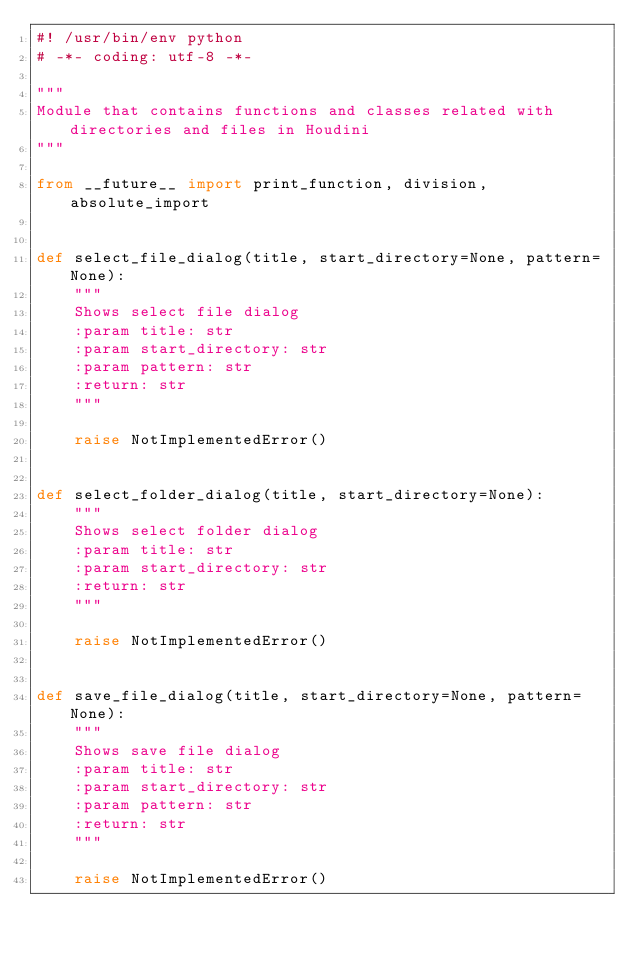<code> <loc_0><loc_0><loc_500><loc_500><_Python_>#! /usr/bin/env python
# -*- coding: utf-8 -*-

"""
Module that contains functions and classes related with directories and files in Houdini
"""

from __future__ import print_function, division, absolute_import


def select_file_dialog(title, start_directory=None, pattern=None):
    """
    Shows select file dialog
    :param title: str
    :param start_directory: str
    :param pattern: str
    :return: str
    """

    raise NotImplementedError()


def select_folder_dialog(title, start_directory=None):
    """
    Shows select folder dialog
    :param title: str
    :param start_directory: str
    :return: str
    """

    raise NotImplementedError()


def save_file_dialog(title, start_directory=None, pattern=None):
    """
    Shows save file dialog
    :param title: str
    :param start_directory: str
    :param pattern: str
    :return: str
    """

    raise NotImplementedError()
</code> 